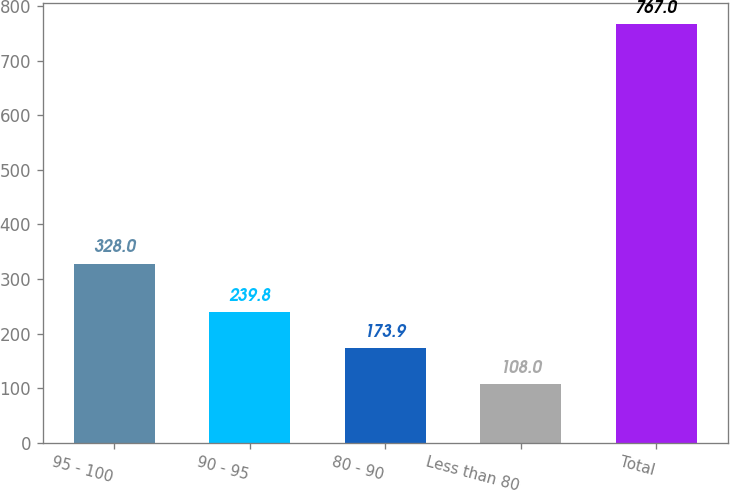<chart> <loc_0><loc_0><loc_500><loc_500><bar_chart><fcel>95 - 100<fcel>90 - 95<fcel>80 - 90<fcel>Less than 80<fcel>Total<nl><fcel>328<fcel>239.8<fcel>173.9<fcel>108<fcel>767<nl></chart> 